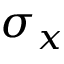Convert formula to latex. <formula><loc_0><loc_0><loc_500><loc_500>\sigma _ { x }</formula> 